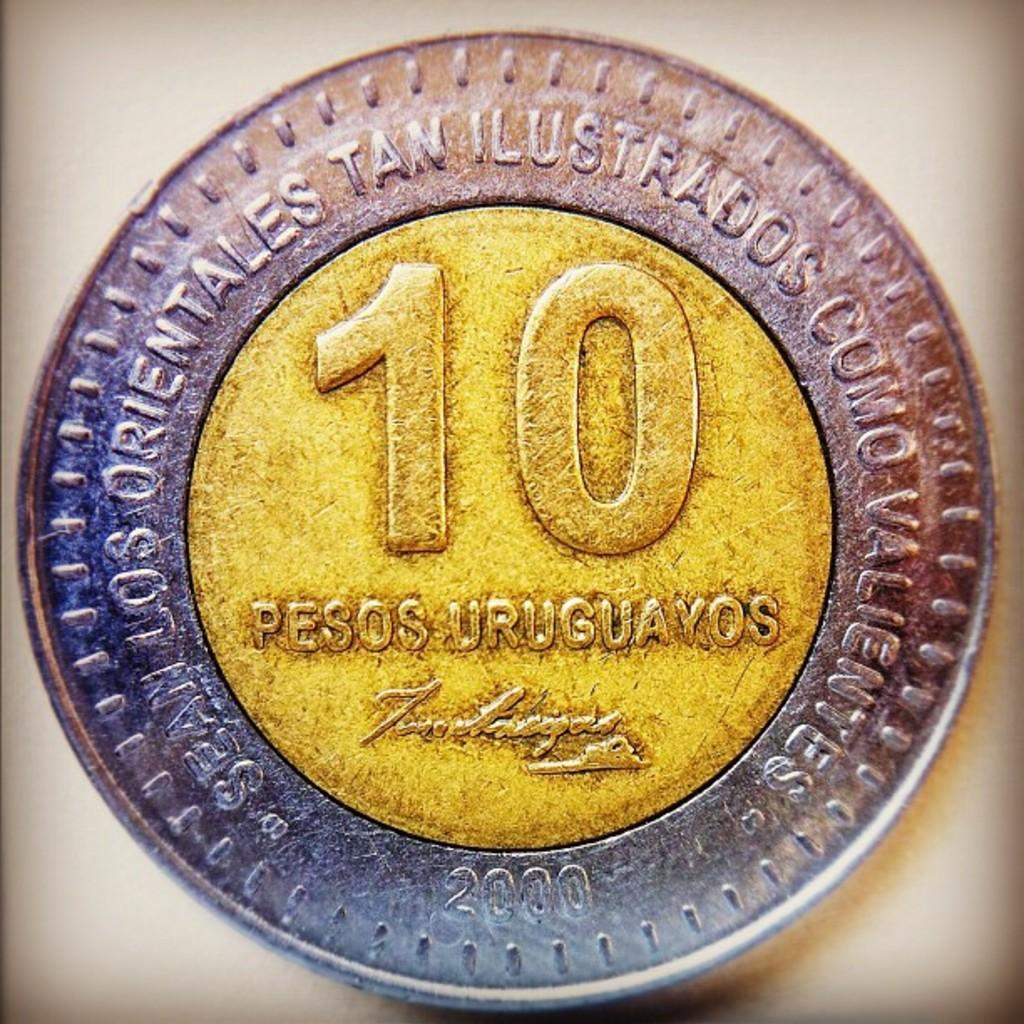<image>
Give a short and clear explanation of the subsequent image. a 10 Pesos Uruguavos coin in silver and bronze 